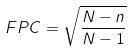Convert formula to latex. <formula><loc_0><loc_0><loc_500><loc_500>F P C = \sqrt { \frac { N - n } { N - 1 } }</formula> 